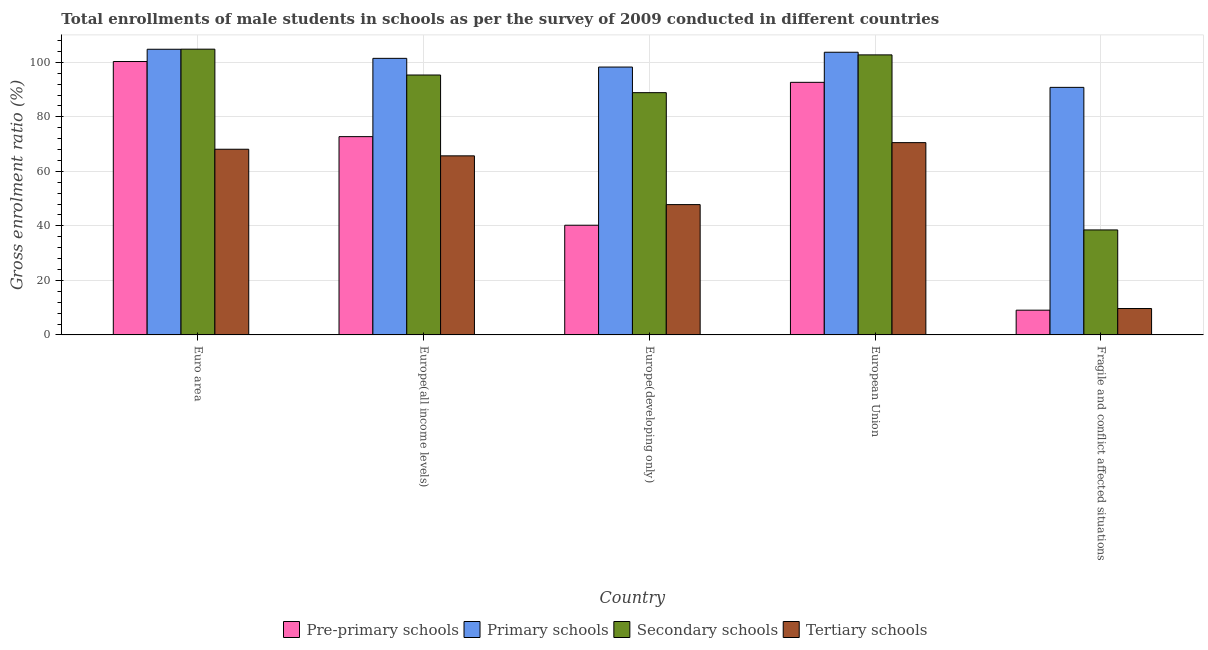Are the number of bars on each tick of the X-axis equal?
Ensure brevity in your answer.  Yes. How many bars are there on the 5th tick from the left?
Give a very brief answer. 4. What is the label of the 4th group of bars from the left?
Keep it short and to the point. European Union. What is the gross enrolment ratio(male) in pre-primary schools in Europe(developing only)?
Offer a very short reply. 40.23. Across all countries, what is the maximum gross enrolment ratio(male) in pre-primary schools?
Your response must be concise. 100.29. Across all countries, what is the minimum gross enrolment ratio(male) in secondary schools?
Keep it short and to the point. 38.51. In which country was the gross enrolment ratio(male) in pre-primary schools maximum?
Give a very brief answer. Euro area. In which country was the gross enrolment ratio(male) in primary schools minimum?
Your answer should be very brief. Fragile and conflict affected situations. What is the total gross enrolment ratio(male) in secondary schools in the graph?
Your answer should be compact. 430.25. What is the difference between the gross enrolment ratio(male) in primary schools in Europe(all income levels) and that in Fragile and conflict affected situations?
Offer a terse response. 10.64. What is the difference between the gross enrolment ratio(male) in tertiary schools in Euro area and the gross enrolment ratio(male) in pre-primary schools in Europe(developing only)?
Offer a very short reply. 27.87. What is the average gross enrolment ratio(male) in tertiary schools per country?
Offer a very short reply. 52.36. What is the difference between the gross enrolment ratio(male) in secondary schools and gross enrolment ratio(male) in tertiary schools in European Union?
Your answer should be very brief. 32.19. In how many countries, is the gross enrolment ratio(male) in tertiary schools greater than 28 %?
Provide a short and direct response. 4. What is the ratio of the gross enrolment ratio(male) in secondary schools in Europe(all income levels) to that in European Union?
Make the answer very short. 0.93. What is the difference between the highest and the second highest gross enrolment ratio(male) in secondary schools?
Provide a succinct answer. 2.1. What is the difference between the highest and the lowest gross enrolment ratio(male) in pre-primary schools?
Keep it short and to the point. 91.21. Is the sum of the gross enrolment ratio(male) in tertiary schools in Europe(all income levels) and European Union greater than the maximum gross enrolment ratio(male) in primary schools across all countries?
Ensure brevity in your answer.  Yes. What does the 2nd bar from the left in Euro area represents?
Offer a very short reply. Primary schools. What does the 4th bar from the right in Euro area represents?
Offer a very short reply. Pre-primary schools. What is the difference between two consecutive major ticks on the Y-axis?
Offer a very short reply. 20. Are the values on the major ticks of Y-axis written in scientific E-notation?
Make the answer very short. No. Does the graph contain any zero values?
Your answer should be compact. No. How many legend labels are there?
Make the answer very short. 4. What is the title of the graph?
Ensure brevity in your answer.  Total enrollments of male students in schools as per the survey of 2009 conducted in different countries. Does "Energy" appear as one of the legend labels in the graph?
Your answer should be very brief. No. What is the label or title of the Y-axis?
Provide a succinct answer. Gross enrolment ratio (%). What is the Gross enrolment ratio (%) in Pre-primary schools in Euro area?
Make the answer very short. 100.29. What is the Gross enrolment ratio (%) in Primary schools in Euro area?
Your response must be concise. 104.78. What is the Gross enrolment ratio (%) in Secondary schools in Euro area?
Give a very brief answer. 104.82. What is the Gross enrolment ratio (%) of Tertiary schools in Euro area?
Provide a succinct answer. 68.11. What is the Gross enrolment ratio (%) of Pre-primary schools in Europe(all income levels)?
Your answer should be compact. 72.73. What is the Gross enrolment ratio (%) of Primary schools in Europe(all income levels)?
Keep it short and to the point. 101.45. What is the Gross enrolment ratio (%) in Secondary schools in Europe(all income levels)?
Your answer should be compact. 95.34. What is the Gross enrolment ratio (%) of Tertiary schools in Europe(all income levels)?
Provide a succinct answer. 65.68. What is the Gross enrolment ratio (%) in Pre-primary schools in Europe(developing only)?
Your answer should be compact. 40.23. What is the Gross enrolment ratio (%) of Primary schools in Europe(developing only)?
Make the answer very short. 98.25. What is the Gross enrolment ratio (%) of Secondary schools in Europe(developing only)?
Keep it short and to the point. 88.86. What is the Gross enrolment ratio (%) in Tertiary schools in Europe(developing only)?
Provide a short and direct response. 47.8. What is the Gross enrolment ratio (%) of Pre-primary schools in European Union?
Offer a terse response. 92.65. What is the Gross enrolment ratio (%) in Primary schools in European Union?
Offer a terse response. 103.69. What is the Gross enrolment ratio (%) of Secondary schools in European Union?
Offer a terse response. 102.72. What is the Gross enrolment ratio (%) of Tertiary schools in European Union?
Keep it short and to the point. 70.53. What is the Gross enrolment ratio (%) of Pre-primary schools in Fragile and conflict affected situations?
Give a very brief answer. 9.07. What is the Gross enrolment ratio (%) in Primary schools in Fragile and conflict affected situations?
Provide a succinct answer. 90.81. What is the Gross enrolment ratio (%) of Secondary schools in Fragile and conflict affected situations?
Give a very brief answer. 38.51. What is the Gross enrolment ratio (%) in Tertiary schools in Fragile and conflict affected situations?
Provide a succinct answer. 9.68. Across all countries, what is the maximum Gross enrolment ratio (%) in Pre-primary schools?
Provide a short and direct response. 100.29. Across all countries, what is the maximum Gross enrolment ratio (%) of Primary schools?
Your response must be concise. 104.78. Across all countries, what is the maximum Gross enrolment ratio (%) of Secondary schools?
Provide a succinct answer. 104.82. Across all countries, what is the maximum Gross enrolment ratio (%) of Tertiary schools?
Make the answer very short. 70.53. Across all countries, what is the minimum Gross enrolment ratio (%) of Pre-primary schools?
Make the answer very short. 9.07. Across all countries, what is the minimum Gross enrolment ratio (%) of Primary schools?
Ensure brevity in your answer.  90.81. Across all countries, what is the minimum Gross enrolment ratio (%) in Secondary schools?
Ensure brevity in your answer.  38.51. Across all countries, what is the minimum Gross enrolment ratio (%) of Tertiary schools?
Your response must be concise. 9.68. What is the total Gross enrolment ratio (%) in Pre-primary schools in the graph?
Your response must be concise. 314.98. What is the total Gross enrolment ratio (%) in Primary schools in the graph?
Give a very brief answer. 498.99. What is the total Gross enrolment ratio (%) in Secondary schools in the graph?
Your answer should be compact. 430.25. What is the total Gross enrolment ratio (%) of Tertiary schools in the graph?
Make the answer very short. 261.81. What is the difference between the Gross enrolment ratio (%) of Pre-primary schools in Euro area and that in Europe(all income levels)?
Make the answer very short. 27.55. What is the difference between the Gross enrolment ratio (%) in Primary schools in Euro area and that in Europe(all income levels)?
Provide a succinct answer. 3.34. What is the difference between the Gross enrolment ratio (%) in Secondary schools in Euro area and that in Europe(all income levels)?
Your response must be concise. 9.48. What is the difference between the Gross enrolment ratio (%) in Tertiary schools in Euro area and that in Europe(all income levels)?
Your answer should be compact. 2.42. What is the difference between the Gross enrolment ratio (%) of Pre-primary schools in Euro area and that in Europe(developing only)?
Give a very brief answer. 60.05. What is the difference between the Gross enrolment ratio (%) in Primary schools in Euro area and that in Europe(developing only)?
Offer a very short reply. 6.53. What is the difference between the Gross enrolment ratio (%) of Secondary schools in Euro area and that in Europe(developing only)?
Provide a short and direct response. 15.96. What is the difference between the Gross enrolment ratio (%) in Tertiary schools in Euro area and that in Europe(developing only)?
Your answer should be very brief. 20.3. What is the difference between the Gross enrolment ratio (%) of Pre-primary schools in Euro area and that in European Union?
Your answer should be compact. 7.64. What is the difference between the Gross enrolment ratio (%) in Primary schools in Euro area and that in European Union?
Your answer should be very brief. 1.09. What is the difference between the Gross enrolment ratio (%) in Secondary schools in Euro area and that in European Union?
Provide a short and direct response. 2.1. What is the difference between the Gross enrolment ratio (%) in Tertiary schools in Euro area and that in European Union?
Provide a short and direct response. -2.43. What is the difference between the Gross enrolment ratio (%) of Pre-primary schools in Euro area and that in Fragile and conflict affected situations?
Your response must be concise. 91.21. What is the difference between the Gross enrolment ratio (%) of Primary schools in Euro area and that in Fragile and conflict affected situations?
Offer a terse response. 13.98. What is the difference between the Gross enrolment ratio (%) of Secondary schools in Euro area and that in Fragile and conflict affected situations?
Make the answer very short. 66.31. What is the difference between the Gross enrolment ratio (%) of Tertiary schools in Euro area and that in Fragile and conflict affected situations?
Make the answer very short. 58.42. What is the difference between the Gross enrolment ratio (%) in Pre-primary schools in Europe(all income levels) and that in Europe(developing only)?
Provide a succinct answer. 32.5. What is the difference between the Gross enrolment ratio (%) of Primary schools in Europe(all income levels) and that in Europe(developing only)?
Ensure brevity in your answer.  3.19. What is the difference between the Gross enrolment ratio (%) in Secondary schools in Europe(all income levels) and that in Europe(developing only)?
Make the answer very short. 6.47. What is the difference between the Gross enrolment ratio (%) of Tertiary schools in Europe(all income levels) and that in Europe(developing only)?
Keep it short and to the point. 17.88. What is the difference between the Gross enrolment ratio (%) in Pre-primary schools in Europe(all income levels) and that in European Union?
Your answer should be compact. -19.92. What is the difference between the Gross enrolment ratio (%) of Primary schools in Europe(all income levels) and that in European Union?
Offer a terse response. -2.24. What is the difference between the Gross enrolment ratio (%) in Secondary schools in Europe(all income levels) and that in European Union?
Ensure brevity in your answer.  -7.38. What is the difference between the Gross enrolment ratio (%) in Tertiary schools in Europe(all income levels) and that in European Union?
Give a very brief answer. -4.85. What is the difference between the Gross enrolment ratio (%) in Pre-primary schools in Europe(all income levels) and that in Fragile and conflict affected situations?
Provide a short and direct response. 63.66. What is the difference between the Gross enrolment ratio (%) of Primary schools in Europe(all income levels) and that in Fragile and conflict affected situations?
Your answer should be very brief. 10.64. What is the difference between the Gross enrolment ratio (%) of Secondary schools in Europe(all income levels) and that in Fragile and conflict affected situations?
Your answer should be compact. 56.83. What is the difference between the Gross enrolment ratio (%) of Tertiary schools in Europe(all income levels) and that in Fragile and conflict affected situations?
Give a very brief answer. 56. What is the difference between the Gross enrolment ratio (%) of Pre-primary schools in Europe(developing only) and that in European Union?
Your answer should be compact. -52.42. What is the difference between the Gross enrolment ratio (%) in Primary schools in Europe(developing only) and that in European Union?
Your answer should be very brief. -5.44. What is the difference between the Gross enrolment ratio (%) in Secondary schools in Europe(developing only) and that in European Union?
Make the answer very short. -13.86. What is the difference between the Gross enrolment ratio (%) in Tertiary schools in Europe(developing only) and that in European Union?
Provide a short and direct response. -22.73. What is the difference between the Gross enrolment ratio (%) of Pre-primary schools in Europe(developing only) and that in Fragile and conflict affected situations?
Your answer should be very brief. 31.16. What is the difference between the Gross enrolment ratio (%) of Primary schools in Europe(developing only) and that in Fragile and conflict affected situations?
Provide a succinct answer. 7.45. What is the difference between the Gross enrolment ratio (%) in Secondary schools in Europe(developing only) and that in Fragile and conflict affected situations?
Offer a very short reply. 50.35. What is the difference between the Gross enrolment ratio (%) of Tertiary schools in Europe(developing only) and that in Fragile and conflict affected situations?
Provide a short and direct response. 38.12. What is the difference between the Gross enrolment ratio (%) of Pre-primary schools in European Union and that in Fragile and conflict affected situations?
Provide a short and direct response. 83.58. What is the difference between the Gross enrolment ratio (%) of Primary schools in European Union and that in Fragile and conflict affected situations?
Give a very brief answer. 12.88. What is the difference between the Gross enrolment ratio (%) in Secondary schools in European Union and that in Fragile and conflict affected situations?
Keep it short and to the point. 64.21. What is the difference between the Gross enrolment ratio (%) of Tertiary schools in European Union and that in Fragile and conflict affected situations?
Offer a terse response. 60.85. What is the difference between the Gross enrolment ratio (%) in Pre-primary schools in Euro area and the Gross enrolment ratio (%) in Primary schools in Europe(all income levels)?
Your response must be concise. -1.16. What is the difference between the Gross enrolment ratio (%) of Pre-primary schools in Euro area and the Gross enrolment ratio (%) of Secondary schools in Europe(all income levels)?
Make the answer very short. 4.95. What is the difference between the Gross enrolment ratio (%) in Pre-primary schools in Euro area and the Gross enrolment ratio (%) in Tertiary schools in Europe(all income levels)?
Provide a short and direct response. 34.6. What is the difference between the Gross enrolment ratio (%) of Primary schools in Euro area and the Gross enrolment ratio (%) of Secondary schools in Europe(all income levels)?
Make the answer very short. 9.45. What is the difference between the Gross enrolment ratio (%) of Primary schools in Euro area and the Gross enrolment ratio (%) of Tertiary schools in Europe(all income levels)?
Give a very brief answer. 39.1. What is the difference between the Gross enrolment ratio (%) in Secondary schools in Euro area and the Gross enrolment ratio (%) in Tertiary schools in Europe(all income levels)?
Ensure brevity in your answer.  39.14. What is the difference between the Gross enrolment ratio (%) of Pre-primary schools in Euro area and the Gross enrolment ratio (%) of Primary schools in Europe(developing only)?
Your response must be concise. 2.03. What is the difference between the Gross enrolment ratio (%) of Pre-primary schools in Euro area and the Gross enrolment ratio (%) of Secondary schools in Europe(developing only)?
Offer a terse response. 11.42. What is the difference between the Gross enrolment ratio (%) of Pre-primary schools in Euro area and the Gross enrolment ratio (%) of Tertiary schools in Europe(developing only)?
Offer a terse response. 52.48. What is the difference between the Gross enrolment ratio (%) of Primary schools in Euro area and the Gross enrolment ratio (%) of Secondary schools in Europe(developing only)?
Offer a very short reply. 15.92. What is the difference between the Gross enrolment ratio (%) in Primary schools in Euro area and the Gross enrolment ratio (%) in Tertiary schools in Europe(developing only)?
Your answer should be very brief. 56.98. What is the difference between the Gross enrolment ratio (%) of Secondary schools in Euro area and the Gross enrolment ratio (%) of Tertiary schools in Europe(developing only)?
Offer a very short reply. 57.02. What is the difference between the Gross enrolment ratio (%) of Pre-primary schools in Euro area and the Gross enrolment ratio (%) of Primary schools in European Union?
Make the answer very short. -3.41. What is the difference between the Gross enrolment ratio (%) in Pre-primary schools in Euro area and the Gross enrolment ratio (%) in Secondary schools in European Union?
Ensure brevity in your answer.  -2.43. What is the difference between the Gross enrolment ratio (%) of Pre-primary schools in Euro area and the Gross enrolment ratio (%) of Tertiary schools in European Union?
Make the answer very short. 29.75. What is the difference between the Gross enrolment ratio (%) in Primary schools in Euro area and the Gross enrolment ratio (%) in Secondary schools in European Union?
Give a very brief answer. 2.06. What is the difference between the Gross enrolment ratio (%) in Primary schools in Euro area and the Gross enrolment ratio (%) in Tertiary schools in European Union?
Keep it short and to the point. 34.25. What is the difference between the Gross enrolment ratio (%) of Secondary schools in Euro area and the Gross enrolment ratio (%) of Tertiary schools in European Union?
Keep it short and to the point. 34.29. What is the difference between the Gross enrolment ratio (%) in Pre-primary schools in Euro area and the Gross enrolment ratio (%) in Primary schools in Fragile and conflict affected situations?
Offer a very short reply. 9.48. What is the difference between the Gross enrolment ratio (%) in Pre-primary schools in Euro area and the Gross enrolment ratio (%) in Secondary schools in Fragile and conflict affected situations?
Provide a succinct answer. 61.78. What is the difference between the Gross enrolment ratio (%) in Pre-primary schools in Euro area and the Gross enrolment ratio (%) in Tertiary schools in Fragile and conflict affected situations?
Your answer should be compact. 90.6. What is the difference between the Gross enrolment ratio (%) of Primary schools in Euro area and the Gross enrolment ratio (%) of Secondary schools in Fragile and conflict affected situations?
Your answer should be very brief. 66.27. What is the difference between the Gross enrolment ratio (%) of Primary schools in Euro area and the Gross enrolment ratio (%) of Tertiary schools in Fragile and conflict affected situations?
Keep it short and to the point. 95.1. What is the difference between the Gross enrolment ratio (%) of Secondary schools in Euro area and the Gross enrolment ratio (%) of Tertiary schools in Fragile and conflict affected situations?
Keep it short and to the point. 95.14. What is the difference between the Gross enrolment ratio (%) in Pre-primary schools in Europe(all income levels) and the Gross enrolment ratio (%) in Primary schools in Europe(developing only)?
Give a very brief answer. -25.52. What is the difference between the Gross enrolment ratio (%) of Pre-primary schools in Europe(all income levels) and the Gross enrolment ratio (%) of Secondary schools in Europe(developing only)?
Your response must be concise. -16.13. What is the difference between the Gross enrolment ratio (%) in Pre-primary schools in Europe(all income levels) and the Gross enrolment ratio (%) in Tertiary schools in Europe(developing only)?
Provide a succinct answer. 24.93. What is the difference between the Gross enrolment ratio (%) in Primary schools in Europe(all income levels) and the Gross enrolment ratio (%) in Secondary schools in Europe(developing only)?
Offer a terse response. 12.59. What is the difference between the Gross enrolment ratio (%) in Primary schools in Europe(all income levels) and the Gross enrolment ratio (%) in Tertiary schools in Europe(developing only)?
Give a very brief answer. 53.65. What is the difference between the Gross enrolment ratio (%) of Secondary schools in Europe(all income levels) and the Gross enrolment ratio (%) of Tertiary schools in Europe(developing only)?
Make the answer very short. 47.53. What is the difference between the Gross enrolment ratio (%) of Pre-primary schools in Europe(all income levels) and the Gross enrolment ratio (%) of Primary schools in European Union?
Your answer should be compact. -30.96. What is the difference between the Gross enrolment ratio (%) of Pre-primary schools in Europe(all income levels) and the Gross enrolment ratio (%) of Secondary schools in European Union?
Ensure brevity in your answer.  -29.99. What is the difference between the Gross enrolment ratio (%) of Pre-primary schools in Europe(all income levels) and the Gross enrolment ratio (%) of Tertiary schools in European Union?
Offer a terse response. 2.2. What is the difference between the Gross enrolment ratio (%) in Primary schools in Europe(all income levels) and the Gross enrolment ratio (%) in Secondary schools in European Union?
Provide a succinct answer. -1.27. What is the difference between the Gross enrolment ratio (%) of Primary schools in Europe(all income levels) and the Gross enrolment ratio (%) of Tertiary schools in European Union?
Offer a terse response. 30.92. What is the difference between the Gross enrolment ratio (%) in Secondary schools in Europe(all income levels) and the Gross enrolment ratio (%) in Tertiary schools in European Union?
Your response must be concise. 24.81. What is the difference between the Gross enrolment ratio (%) in Pre-primary schools in Europe(all income levels) and the Gross enrolment ratio (%) in Primary schools in Fragile and conflict affected situations?
Make the answer very short. -18.07. What is the difference between the Gross enrolment ratio (%) of Pre-primary schools in Europe(all income levels) and the Gross enrolment ratio (%) of Secondary schools in Fragile and conflict affected situations?
Make the answer very short. 34.22. What is the difference between the Gross enrolment ratio (%) in Pre-primary schools in Europe(all income levels) and the Gross enrolment ratio (%) in Tertiary schools in Fragile and conflict affected situations?
Keep it short and to the point. 63.05. What is the difference between the Gross enrolment ratio (%) in Primary schools in Europe(all income levels) and the Gross enrolment ratio (%) in Secondary schools in Fragile and conflict affected situations?
Keep it short and to the point. 62.94. What is the difference between the Gross enrolment ratio (%) of Primary schools in Europe(all income levels) and the Gross enrolment ratio (%) of Tertiary schools in Fragile and conflict affected situations?
Offer a very short reply. 91.77. What is the difference between the Gross enrolment ratio (%) of Secondary schools in Europe(all income levels) and the Gross enrolment ratio (%) of Tertiary schools in Fragile and conflict affected situations?
Your response must be concise. 85.66. What is the difference between the Gross enrolment ratio (%) of Pre-primary schools in Europe(developing only) and the Gross enrolment ratio (%) of Primary schools in European Union?
Make the answer very short. -63.46. What is the difference between the Gross enrolment ratio (%) in Pre-primary schools in Europe(developing only) and the Gross enrolment ratio (%) in Secondary schools in European Union?
Your answer should be compact. -62.49. What is the difference between the Gross enrolment ratio (%) in Pre-primary schools in Europe(developing only) and the Gross enrolment ratio (%) in Tertiary schools in European Union?
Make the answer very short. -30.3. What is the difference between the Gross enrolment ratio (%) of Primary schools in Europe(developing only) and the Gross enrolment ratio (%) of Secondary schools in European Union?
Give a very brief answer. -4.47. What is the difference between the Gross enrolment ratio (%) in Primary schools in Europe(developing only) and the Gross enrolment ratio (%) in Tertiary schools in European Union?
Your response must be concise. 27.72. What is the difference between the Gross enrolment ratio (%) of Secondary schools in Europe(developing only) and the Gross enrolment ratio (%) of Tertiary schools in European Union?
Make the answer very short. 18.33. What is the difference between the Gross enrolment ratio (%) of Pre-primary schools in Europe(developing only) and the Gross enrolment ratio (%) of Primary schools in Fragile and conflict affected situations?
Your answer should be compact. -50.57. What is the difference between the Gross enrolment ratio (%) of Pre-primary schools in Europe(developing only) and the Gross enrolment ratio (%) of Secondary schools in Fragile and conflict affected situations?
Offer a very short reply. 1.72. What is the difference between the Gross enrolment ratio (%) in Pre-primary schools in Europe(developing only) and the Gross enrolment ratio (%) in Tertiary schools in Fragile and conflict affected situations?
Ensure brevity in your answer.  30.55. What is the difference between the Gross enrolment ratio (%) of Primary schools in Europe(developing only) and the Gross enrolment ratio (%) of Secondary schools in Fragile and conflict affected situations?
Give a very brief answer. 59.74. What is the difference between the Gross enrolment ratio (%) in Primary schools in Europe(developing only) and the Gross enrolment ratio (%) in Tertiary schools in Fragile and conflict affected situations?
Provide a short and direct response. 88.57. What is the difference between the Gross enrolment ratio (%) in Secondary schools in Europe(developing only) and the Gross enrolment ratio (%) in Tertiary schools in Fragile and conflict affected situations?
Make the answer very short. 79.18. What is the difference between the Gross enrolment ratio (%) of Pre-primary schools in European Union and the Gross enrolment ratio (%) of Primary schools in Fragile and conflict affected situations?
Keep it short and to the point. 1.84. What is the difference between the Gross enrolment ratio (%) in Pre-primary schools in European Union and the Gross enrolment ratio (%) in Secondary schools in Fragile and conflict affected situations?
Your response must be concise. 54.14. What is the difference between the Gross enrolment ratio (%) of Pre-primary schools in European Union and the Gross enrolment ratio (%) of Tertiary schools in Fragile and conflict affected situations?
Your response must be concise. 82.97. What is the difference between the Gross enrolment ratio (%) in Primary schools in European Union and the Gross enrolment ratio (%) in Secondary schools in Fragile and conflict affected situations?
Offer a terse response. 65.18. What is the difference between the Gross enrolment ratio (%) in Primary schools in European Union and the Gross enrolment ratio (%) in Tertiary schools in Fragile and conflict affected situations?
Provide a succinct answer. 94.01. What is the difference between the Gross enrolment ratio (%) in Secondary schools in European Union and the Gross enrolment ratio (%) in Tertiary schools in Fragile and conflict affected situations?
Offer a very short reply. 93.04. What is the average Gross enrolment ratio (%) of Pre-primary schools per country?
Your answer should be compact. 63. What is the average Gross enrolment ratio (%) of Primary schools per country?
Ensure brevity in your answer.  99.8. What is the average Gross enrolment ratio (%) in Secondary schools per country?
Keep it short and to the point. 86.05. What is the average Gross enrolment ratio (%) in Tertiary schools per country?
Your answer should be very brief. 52.36. What is the difference between the Gross enrolment ratio (%) of Pre-primary schools and Gross enrolment ratio (%) of Primary schools in Euro area?
Provide a short and direct response. -4.5. What is the difference between the Gross enrolment ratio (%) in Pre-primary schools and Gross enrolment ratio (%) in Secondary schools in Euro area?
Offer a terse response. -4.54. What is the difference between the Gross enrolment ratio (%) in Pre-primary schools and Gross enrolment ratio (%) in Tertiary schools in Euro area?
Offer a terse response. 32.18. What is the difference between the Gross enrolment ratio (%) of Primary schools and Gross enrolment ratio (%) of Secondary schools in Euro area?
Keep it short and to the point. -0.04. What is the difference between the Gross enrolment ratio (%) of Primary schools and Gross enrolment ratio (%) of Tertiary schools in Euro area?
Make the answer very short. 36.68. What is the difference between the Gross enrolment ratio (%) in Secondary schools and Gross enrolment ratio (%) in Tertiary schools in Euro area?
Your answer should be compact. 36.71. What is the difference between the Gross enrolment ratio (%) of Pre-primary schools and Gross enrolment ratio (%) of Primary schools in Europe(all income levels)?
Ensure brevity in your answer.  -28.72. What is the difference between the Gross enrolment ratio (%) of Pre-primary schools and Gross enrolment ratio (%) of Secondary schools in Europe(all income levels)?
Ensure brevity in your answer.  -22.6. What is the difference between the Gross enrolment ratio (%) in Pre-primary schools and Gross enrolment ratio (%) in Tertiary schools in Europe(all income levels)?
Provide a succinct answer. 7.05. What is the difference between the Gross enrolment ratio (%) of Primary schools and Gross enrolment ratio (%) of Secondary schools in Europe(all income levels)?
Offer a terse response. 6.11. What is the difference between the Gross enrolment ratio (%) in Primary schools and Gross enrolment ratio (%) in Tertiary schools in Europe(all income levels)?
Your response must be concise. 35.77. What is the difference between the Gross enrolment ratio (%) in Secondary schools and Gross enrolment ratio (%) in Tertiary schools in Europe(all income levels)?
Your answer should be very brief. 29.65. What is the difference between the Gross enrolment ratio (%) in Pre-primary schools and Gross enrolment ratio (%) in Primary schools in Europe(developing only)?
Your answer should be compact. -58.02. What is the difference between the Gross enrolment ratio (%) of Pre-primary schools and Gross enrolment ratio (%) of Secondary schools in Europe(developing only)?
Give a very brief answer. -48.63. What is the difference between the Gross enrolment ratio (%) of Pre-primary schools and Gross enrolment ratio (%) of Tertiary schools in Europe(developing only)?
Your answer should be compact. -7.57. What is the difference between the Gross enrolment ratio (%) in Primary schools and Gross enrolment ratio (%) in Secondary schools in Europe(developing only)?
Your answer should be compact. 9.39. What is the difference between the Gross enrolment ratio (%) of Primary schools and Gross enrolment ratio (%) of Tertiary schools in Europe(developing only)?
Your answer should be very brief. 50.45. What is the difference between the Gross enrolment ratio (%) in Secondary schools and Gross enrolment ratio (%) in Tertiary schools in Europe(developing only)?
Give a very brief answer. 41.06. What is the difference between the Gross enrolment ratio (%) in Pre-primary schools and Gross enrolment ratio (%) in Primary schools in European Union?
Your answer should be compact. -11.04. What is the difference between the Gross enrolment ratio (%) of Pre-primary schools and Gross enrolment ratio (%) of Secondary schools in European Union?
Your answer should be compact. -10.07. What is the difference between the Gross enrolment ratio (%) in Pre-primary schools and Gross enrolment ratio (%) in Tertiary schools in European Union?
Your response must be concise. 22.12. What is the difference between the Gross enrolment ratio (%) of Primary schools and Gross enrolment ratio (%) of Secondary schools in European Union?
Your response must be concise. 0.97. What is the difference between the Gross enrolment ratio (%) of Primary schools and Gross enrolment ratio (%) of Tertiary schools in European Union?
Provide a short and direct response. 33.16. What is the difference between the Gross enrolment ratio (%) of Secondary schools and Gross enrolment ratio (%) of Tertiary schools in European Union?
Provide a succinct answer. 32.19. What is the difference between the Gross enrolment ratio (%) in Pre-primary schools and Gross enrolment ratio (%) in Primary schools in Fragile and conflict affected situations?
Offer a terse response. -81.74. What is the difference between the Gross enrolment ratio (%) of Pre-primary schools and Gross enrolment ratio (%) of Secondary schools in Fragile and conflict affected situations?
Offer a very short reply. -29.44. What is the difference between the Gross enrolment ratio (%) in Pre-primary schools and Gross enrolment ratio (%) in Tertiary schools in Fragile and conflict affected situations?
Your response must be concise. -0.61. What is the difference between the Gross enrolment ratio (%) in Primary schools and Gross enrolment ratio (%) in Secondary schools in Fragile and conflict affected situations?
Ensure brevity in your answer.  52.3. What is the difference between the Gross enrolment ratio (%) of Primary schools and Gross enrolment ratio (%) of Tertiary schools in Fragile and conflict affected situations?
Provide a short and direct response. 81.13. What is the difference between the Gross enrolment ratio (%) of Secondary schools and Gross enrolment ratio (%) of Tertiary schools in Fragile and conflict affected situations?
Your answer should be compact. 28.83. What is the ratio of the Gross enrolment ratio (%) in Pre-primary schools in Euro area to that in Europe(all income levels)?
Provide a succinct answer. 1.38. What is the ratio of the Gross enrolment ratio (%) in Primary schools in Euro area to that in Europe(all income levels)?
Ensure brevity in your answer.  1.03. What is the ratio of the Gross enrolment ratio (%) in Secondary schools in Euro area to that in Europe(all income levels)?
Give a very brief answer. 1.1. What is the ratio of the Gross enrolment ratio (%) of Tertiary schools in Euro area to that in Europe(all income levels)?
Give a very brief answer. 1.04. What is the ratio of the Gross enrolment ratio (%) in Pre-primary schools in Euro area to that in Europe(developing only)?
Offer a terse response. 2.49. What is the ratio of the Gross enrolment ratio (%) of Primary schools in Euro area to that in Europe(developing only)?
Give a very brief answer. 1.07. What is the ratio of the Gross enrolment ratio (%) of Secondary schools in Euro area to that in Europe(developing only)?
Keep it short and to the point. 1.18. What is the ratio of the Gross enrolment ratio (%) in Tertiary schools in Euro area to that in Europe(developing only)?
Keep it short and to the point. 1.42. What is the ratio of the Gross enrolment ratio (%) in Pre-primary schools in Euro area to that in European Union?
Your answer should be compact. 1.08. What is the ratio of the Gross enrolment ratio (%) in Primary schools in Euro area to that in European Union?
Your response must be concise. 1.01. What is the ratio of the Gross enrolment ratio (%) of Secondary schools in Euro area to that in European Union?
Give a very brief answer. 1.02. What is the ratio of the Gross enrolment ratio (%) of Tertiary schools in Euro area to that in European Union?
Offer a very short reply. 0.97. What is the ratio of the Gross enrolment ratio (%) of Pre-primary schools in Euro area to that in Fragile and conflict affected situations?
Your response must be concise. 11.06. What is the ratio of the Gross enrolment ratio (%) in Primary schools in Euro area to that in Fragile and conflict affected situations?
Your answer should be very brief. 1.15. What is the ratio of the Gross enrolment ratio (%) of Secondary schools in Euro area to that in Fragile and conflict affected situations?
Ensure brevity in your answer.  2.72. What is the ratio of the Gross enrolment ratio (%) of Tertiary schools in Euro area to that in Fragile and conflict affected situations?
Provide a short and direct response. 7.03. What is the ratio of the Gross enrolment ratio (%) of Pre-primary schools in Europe(all income levels) to that in Europe(developing only)?
Give a very brief answer. 1.81. What is the ratio of the Gross enrolment ratio (%) in Primary schools in Europe(all income levels) to that in Europe(developing only)?
Ensure brevity in your answer.  1.03. What is the ratio of the Gross enrolment ratio (%) of Secondary schools in Europe(all income levels) to that in Europe(developing only)?
Make the answer very short. 1.07. What is the ratio of the Gross enrolment ratio (%) of Tertiary schools in Europe(all income levels) to that in Europe(developing only)?
Make the answer very short. 1.37. What is the ratio of the Gross enrolment ratio (%) of Pre-primary schools in Europe(all income levels) to that in European Union?
Ensure brevity in your answer.  0.79. What is the ratio of the Gross enrolment ratio (%) of Primary schools in Europe(all income levels) to that in European Union?
Your answer should be compact. 0.98. What is the ratio of the Gross enrolment ratio (%) of Secondary schools in Europe(all income levels) to that in European Union?
Your response must be concise. 0.93. What is the ratio of the Gross enrolment ratio (%) in Tertiary schools in Europe(all income levels) to that in European Union?
Provide a succinct answer. 0.93. What is the ratio of the Gross enrolment ratio (%) in Pre-primary schools in Europe(all income levels) to that in Fragile and conflict affected situations?
Provide a short and direct response. 8.02. What is the ratio of the Gross enrolment ratio (%) of Primary schools in Europe(all income levels) to that in Fragile and conflict affected situations?
Your answer should be very brief. 1.12. What is the ratio of the Gross enrolment ratio (%) in Secondary schools in Europe(all income levels) to that in Fragile and conflict affected situations?
Your answer should be very brief. 2.48. What is the ratio of the Gross enrolment ratio (%) of Tertiary schools in Europe(all income levels) to that in Fragile and conflict affected situations?
Your answer should be very brief. 6.78. What is the ratio of the Gross enrolment ratio (%) in Pre-primary schools in Europe(developing only) to that in European Union?
Provide a succinct answer. 0.43. What is the ratio of the Gross enrolment ratio (%) in Primary schools in Europe(developing only) to that in European Union?
Provide a succinct answer. 0.95. What is the ratio of the Gross enrolment ratio (%) of Secondary schools in Europe(developing only) to that in European Union?
Give a very brief answer. 0.87. What is the ratio of the Gross enrolment ratio (%) in Tertiary schools in Europe(developing only) to that in European Union?
Offer a terse response. 0.68. What is the ratio of the Gross enrolment ratio (%) in Pre-primary schools in Europe(developing only) to that in Fragile and conflict affected situations?
Offer a terse response. 4.44. What is the ratio of the Gross enrolment ratio (%) of Primary schools in Europe(developing only) to that in Fragile and conflict affected situations?
Ensure brevity in your answer.  1.08. What is the ratio of the Gross enrolment ratio (%) in Secondary schools in Europe(developing only) to that in Fragile and conflict affected situations?
Your answer should be compact. 2.31. What is the ratio of the Gross enrolment ratio (%) in Tertiary schools in Europe(developing only) to that in Fragile and conflict affected situations?
Your response must be concise. 4.94. What is the ratio of the Gross enrolment ratio (%) of Pre-primary schools in European Union to that in Fragile and conflict affected situations?
Keep it short and to the point. 10.21. What is the ratio of the Gross enrolment ratio (%) of Primary schools in European Union to that in Fragile and conflict affected situations?
Ensure brevity in your answer.  1.14. What is the ratio of the Gross enrolment ratio (%) in Secondary schools in European Union to that in Fragile and conflict affected situations?
Provide a short and direct response. 2.67. What is the ratio of the Gross enrolment ratio (%) in Tertiary schools in European Union to that in Fragile and conflict affected situations?
Give a very brief answer. 7.28. What is the difference between the highest and the second highest Gross enrolment ratio (%) of Pre-primary schools?
Provide a succinct answer. 7.64. What is the difference between the highest and the second highest Gross enrolment ratio (%) of Primary schools?
Make the answer very short. 1.09. What is the difference between the highest and the second highest Gross enrolment ratio (%) of Secondary schools?
Provide a succinct answer. 2.1. What is the difference between the highest and the second highest Gross enrolment ratio (%) in Tertiary schools?
Provide a short and direct response. 2.43. What is the difference between the highest and the lowest Gross enrolment ratio (%) in Pre-primary schools?
Make the answer very short. 91.21. What is the difference between the highest and the lowest Gross enrolment ratio (%) of Primary schools?
Give a very brief answer. 13.98. What is the difference between the highest and the lowest Gross enrolment ratio (%) in Secondary schools?
Offer a very short reply. 66.31. What is the difference between the highest and the lowest Gross enrolment ratio (%) in Tertiary schools?
Provide a short and direct response. 60.85. 